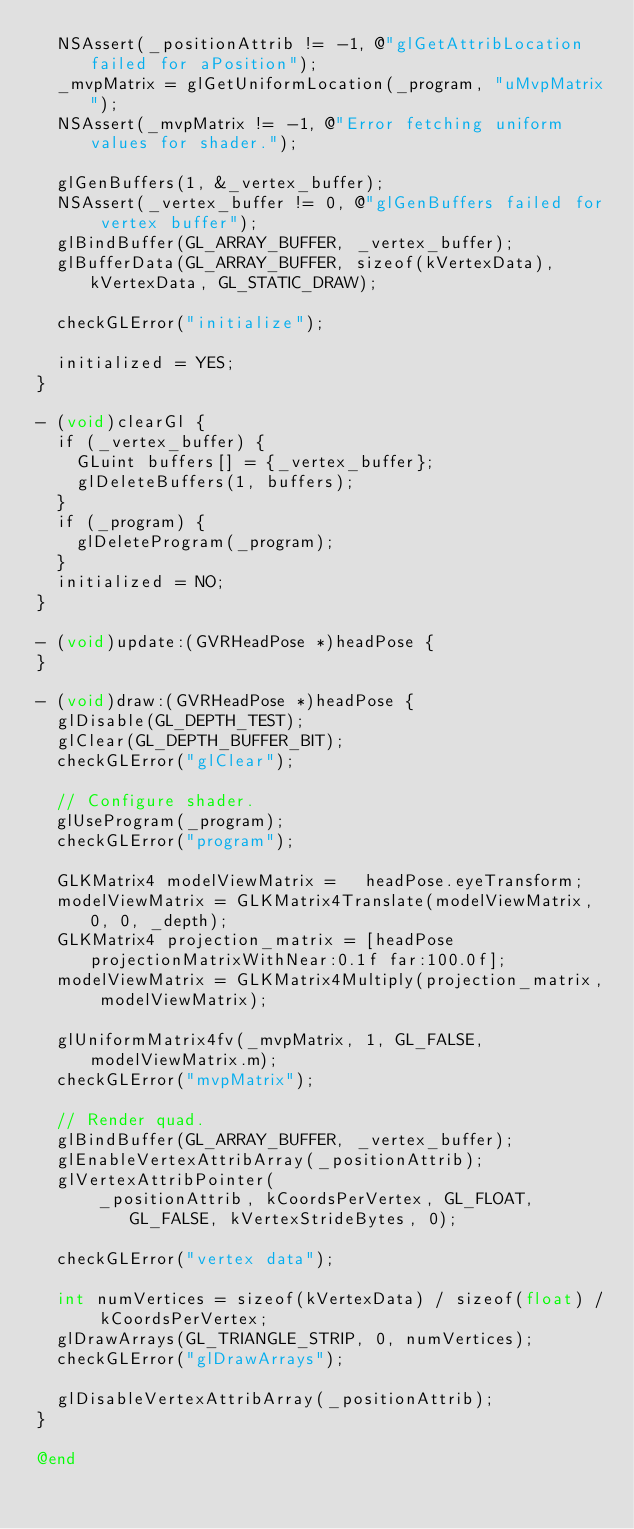Convert code to text. <code><loc_0><loc_0><loc_500><loc_500><_ObjectiveC_>  NSAssert(_positionAttrib != -1, @"glGetAttribLocation failed for aPosition");
  _mvpMatrix = glGetUniformLocation(_program, "uMvpMatrix");
  NSAssert(_mvpMatrix != -1, @"Error fetching uniform values for shader.");

  glGenBuffers(1, &_vertex_buffer);
  NSAssert(_vertex_buffer != 0, @"glGenBuffers failed for vertex buffer");
  glBindBuffer(GL_ARRAY_BUFFER, _vertex_buffer);
  glBufferData(GL_ARRAY_BUFFER, sizeof(kVertexData), kVertexData, GL_STATIC_DRAW);

  checkGLError("initialize");

  initialized = YES;
}

- (void)clearGl {
  if (_vertex_buffer) {
    GLuint buffers[] = {_vertex_buffer};
    glDeleteBuffers(1, buffers);
  }
  if (_program) {
    glDeleteProgram(_program);
  }
  initialized = NO;
}

- (void)update:(GVRHeadPose *)headPose {
}

- (void)draw:(GVRHeadPose *)headPose {
  glDisable(GL_DEPTH_TEST);
  glClear(GL_DEPTH_BUFFER_BIT);
  checkGLError("glClear");

  // Configure shader.
  glUseProgram(_program);
  checkGLError("program");

  GLKMatrix4 modelViewMatrix =   headPose.eyeTransform;
  modelViewMatrix = GLKMatrix4Translate(modelViewMatrix, 0, 0, _depth);
  GLKMatrix4 projection_matrix = [headPose projectionMatrixWithNear:0.1f far:100.0f];
  modelViewMatrix = GLKMatrix4Multiply(projection_matrix, modelViewMatrix);

  glUniformMatrix4fv(_mvpMatrix, 1, GL_FALSE, modelViewMatrix.m);
  checkGLError("mvpMatrix");

  // Render quad.
  glBindBuffer(GL_ARRAY_BUFFER, _vertex_buffer);
  glEnableVertexAttribArray(_positionAttrib);
  glVertexAttribPointer(
      _positionAttrib, kCoordsPerVertex, GL_FLOAT, GL_FALSE, kVertexStrideBytes, 0);

  checkGLError("vertex data");

  int numVertices = sizeof(kVertexData) / sizeof(float) / kCoordsPerVertex;
  glDrawArrays(GL_TRIANGLE_STRIP, 0, numVertices);
  checkGLError("glDrawArrays");

  glDisableVertexAttribArray(_positionAttrib);
}

@end
</code> 